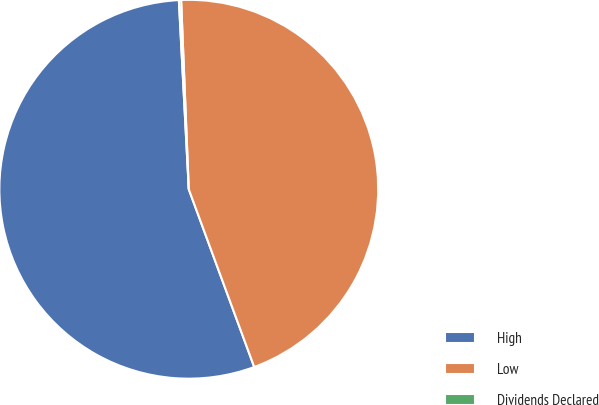<chart> <loc_0><loc_0><loc_500><loc_500><pie_chart><fcel>High<fcel>Low<fcel>Dividends Declared<nl><fcel>54.78%<fcel>45.03%<fcel>0.19%<nl></chart> 